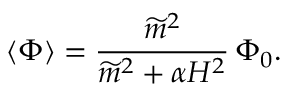Convert formula to latex. <formula><loc_0><loc_0><loc_500><loc_500>\langle \Phi \rangle = \frac { \widetilde { m } ^ { 2 } } { \widetilde { m } ^ { 2 } + \alpha H ^ { 2 } } \, \Phi _ { 0 } .</formula> 